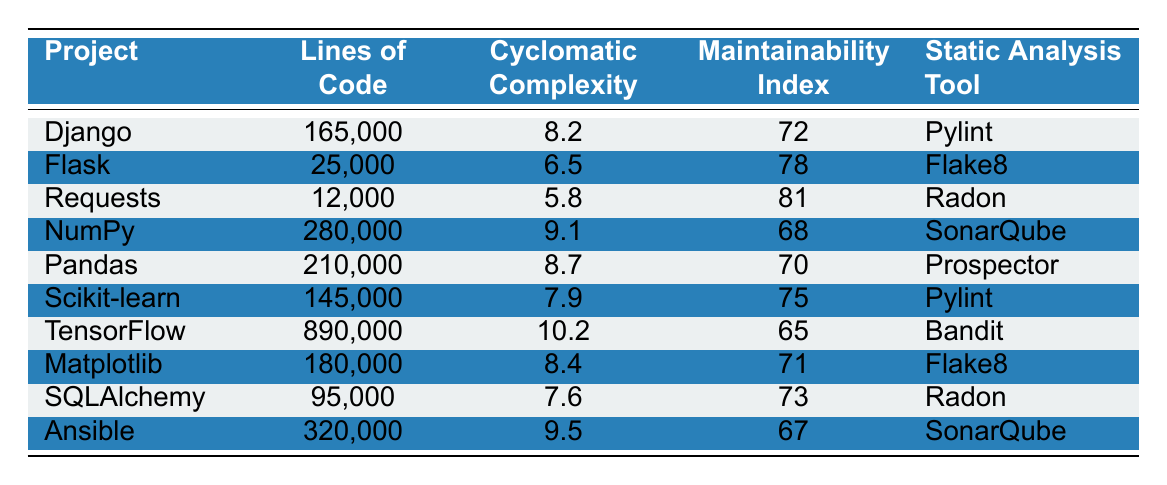What is the Lines of Code for TensorFlow? The Lines of Code for TensorFlow is listed directly in the table under the respective project. At the row for TensorFlow, the Lines of Code value is 890,000.
Answer: 890,000 Which project has the highest Maintainability Index? By scanning the Maintainability Index column, the highest value is found. The highest index of 81 corresponds to the Requests project.
Answer: Requests How many projects have a Cyclomatic Complexity higher than 8? First, I check the Cyclomatic Complexity values of each project in the table. The projects with values above 8 are Django (8.2), NumPy (9.1), Pandas (8.7), TensorFlow (10.2), and Ansible (9.5), making a total of five projects.
Answer: 5 What is the average Maintainability Index of all projects? I first gather all the Maintainability Index values: [72, 78, 81, 68, 70, 75, 65, 71, 73, 67]. Next, I total these values, which is 70.8 (sum = 720, count = 10), and divide by the number of projects (10) to compute the average: 720 / 10 = 72.
Answer: 72 Is the Cyclomatic Complexity of Flask less than that of Scikit-learn? I compare the Cyclomatic Complexity values for Flask and Scikit-learn. Flask has a Cyclomatic Complexity of 6.5, while Scikit-learn has 7.9, indicating that Flask's complexity is less.
Answer: Yes Which static analysis tool is used for the project with the most Lines of Code? I find the project with the most Lines of Code in the table. TensorFlow has the highest Lines of Code at 890,000, and the corresponding static analysis tool listed is Bandit.
Answer: Bandit What is the difference in Lines of Code between Django and Pandas? I first look at the Lines of Code values for Django (165,000) and Pandas (210,000) and then calculate the difference: 210,000 - 165,000 = 45,000.
Answer: 45,000 Does any project use Radon as a static analysis tool? I check the Static Analysis Tool column for any occurrence of Radon. The projects Requests and SQLAlchemy both use Radon, confirming that there are indeed projects that utilize this tool.
Answer: Yes 